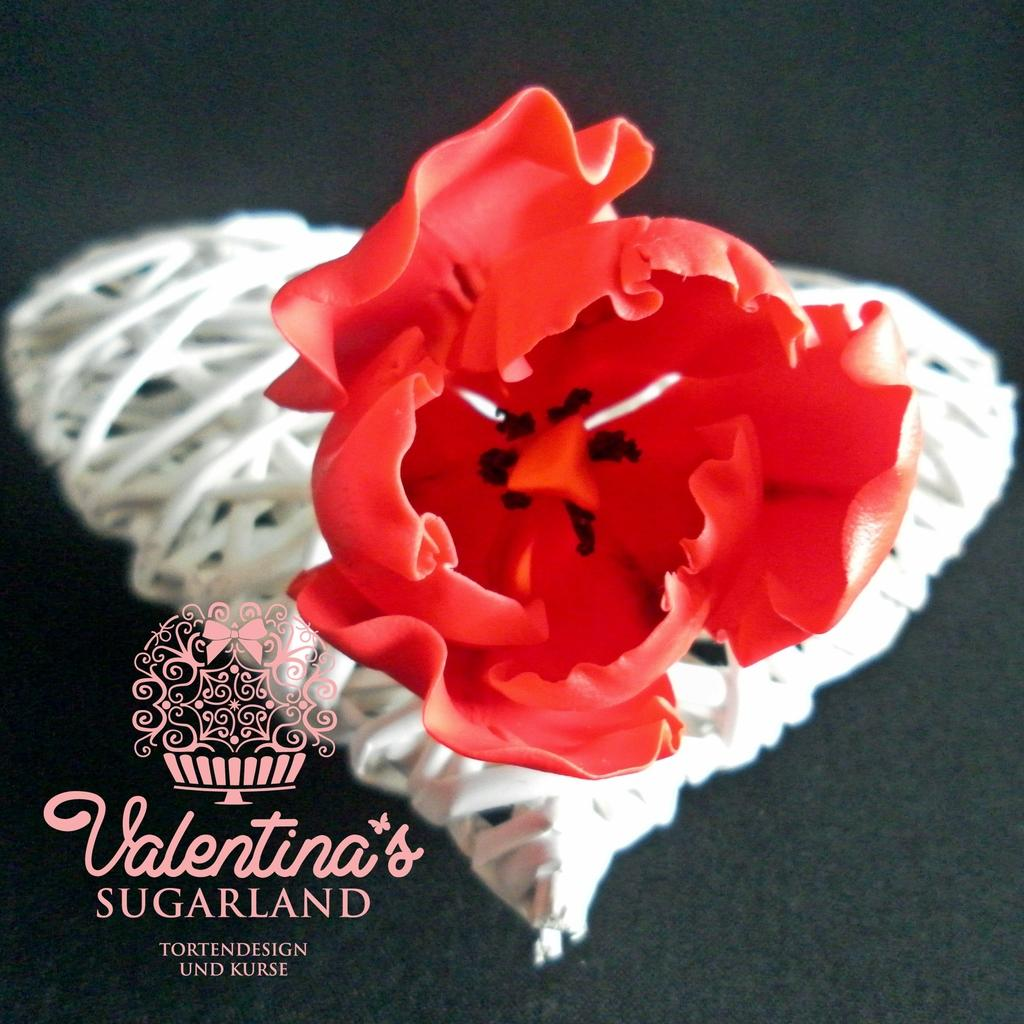What is the color of the object in the image? The object has a white and red color in the image. What is the object placed on? The object is on a black surface. Is there any text or writing on the object? Yes, there is writing on the object. What type of vegetable is growing inside the mailbox in the image? There is no mailbox or vegetable present in the image. 